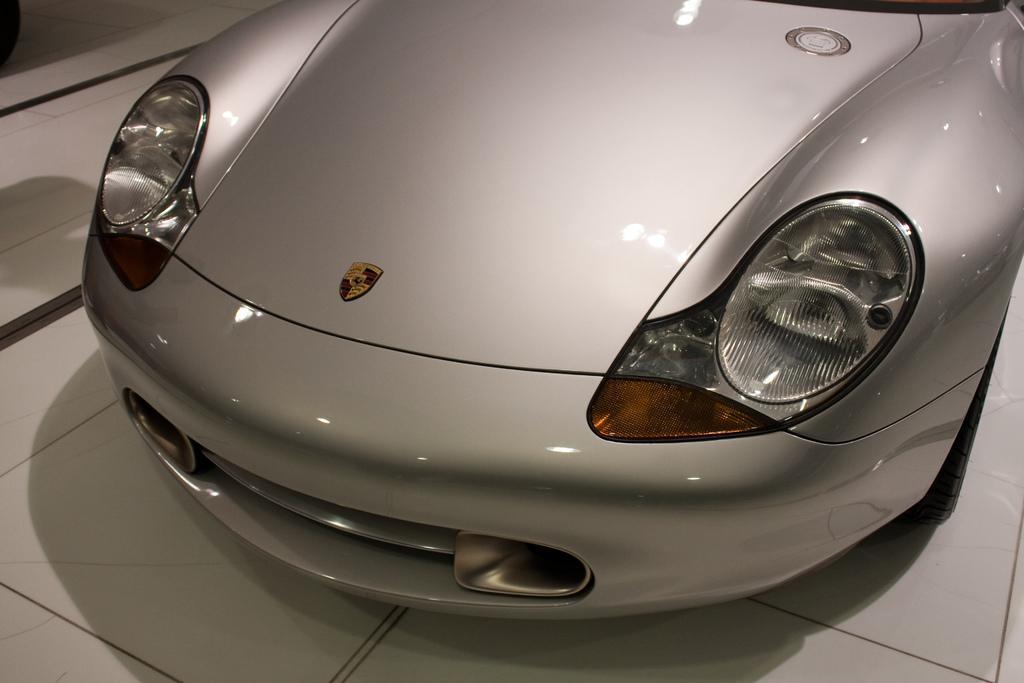Describe this image in one or two sentences. In this image I can see the vehicle which is in ash color. It is on the white color surface. 